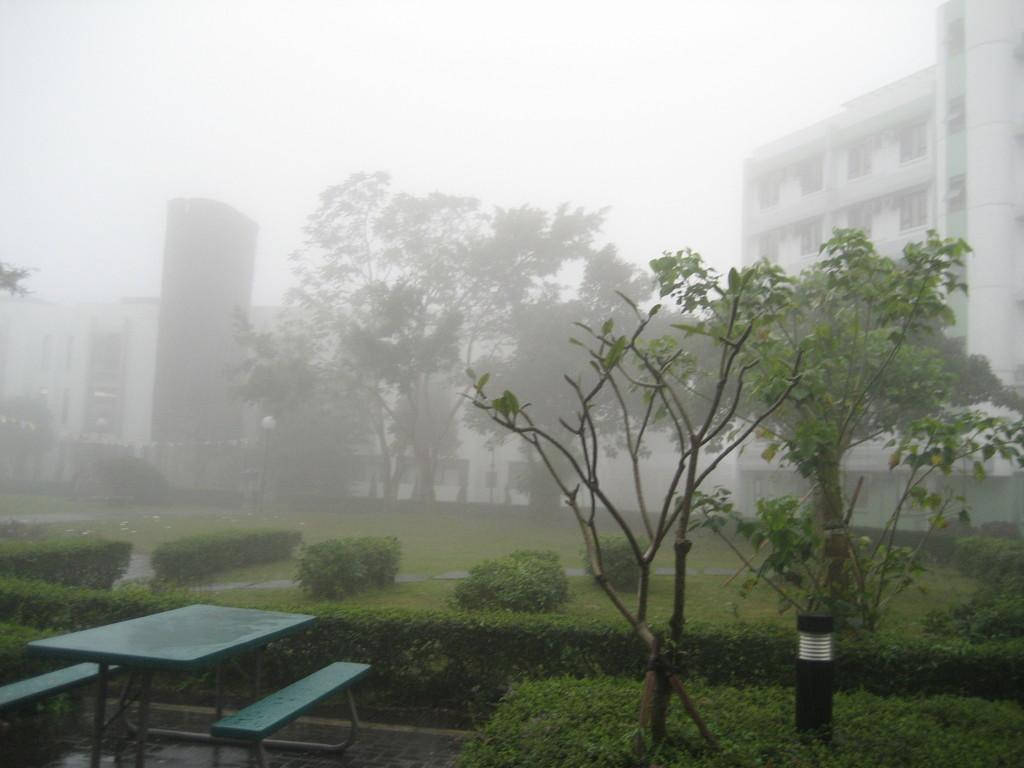In one or two sentences, can you explain what this image depicts? In this image I can see few trees in green color. I can also see two benches and table in green color, background I can see few buildings, and sky in white color. 